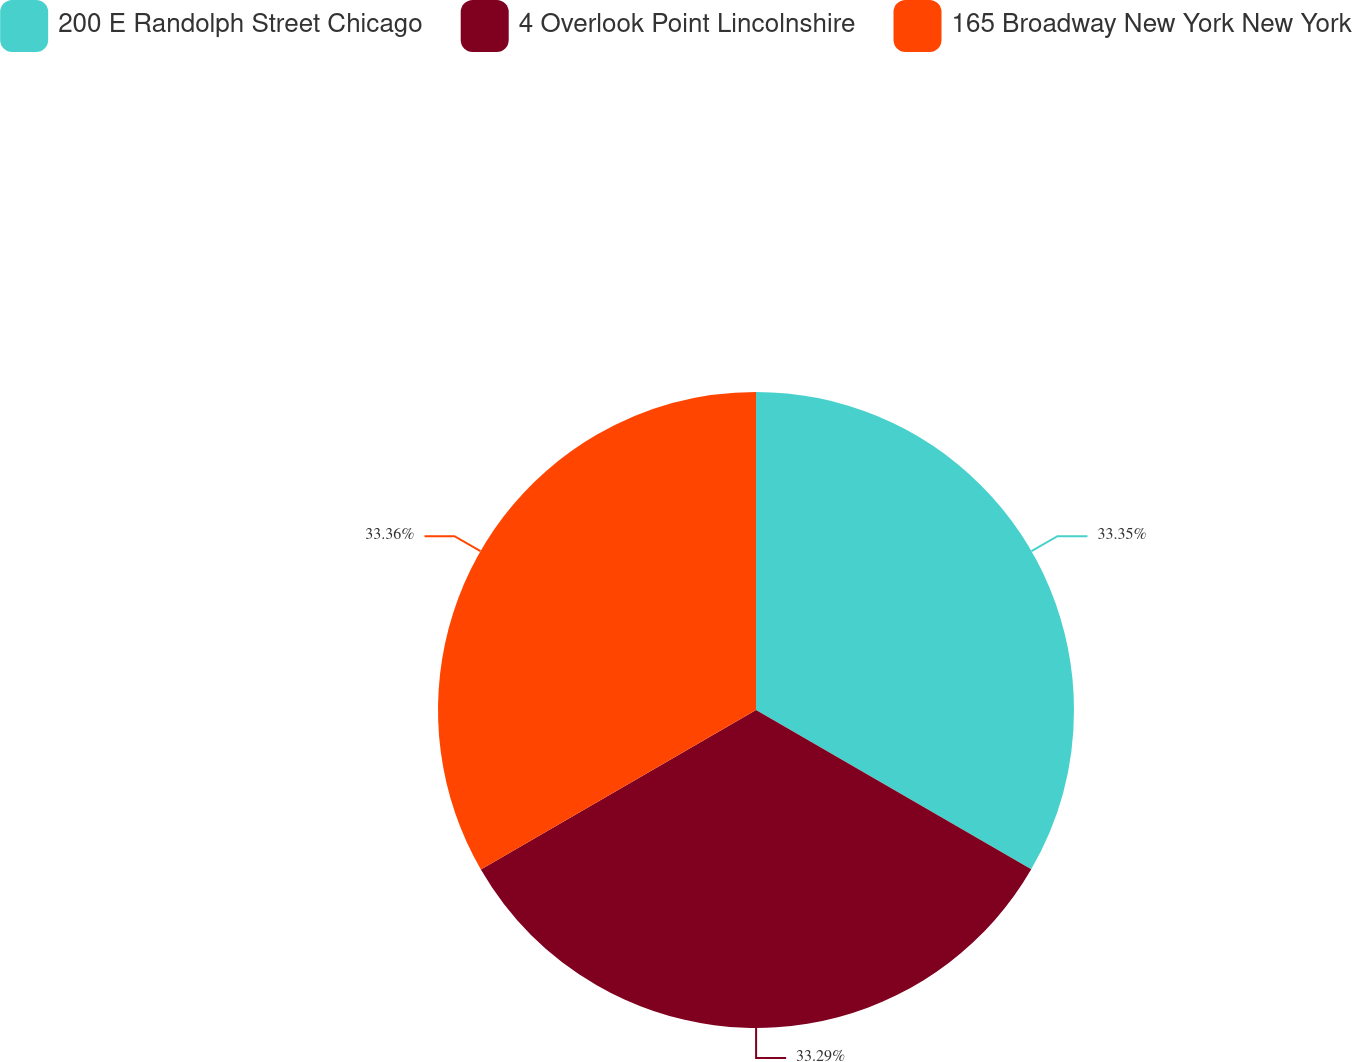<chart> <loc_0><loc_0><loc_500><loc_500><pie_chart><fcel>200 E Randolph Street Chicago<fcel>4 Overlook Point Lincolnshire<fcel>165 Broadway New York New York<nl><fcel>33.35%<fcel>33.29%<fcel>33.36%<nl></chart> 